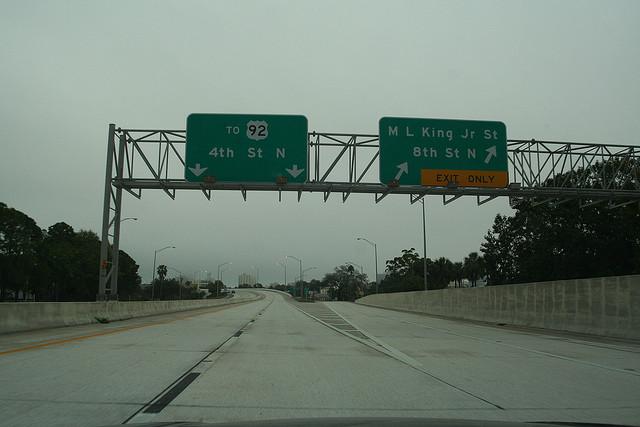Do you go straight or turn to get to 4th Street N?
Write a very short answer. Straight. Is this a highway?
Write a very short answer. Yes. Is the exit on the left or right?
Answer briefly. Right. Is this an Austrian street sign?
Quick response, please. No. 